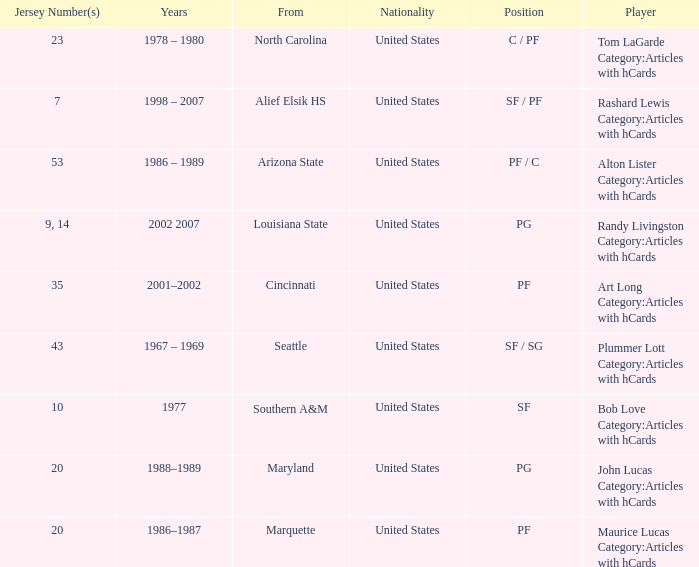Bob Love Category:Articles with hCards is from where? Southern A&M. 